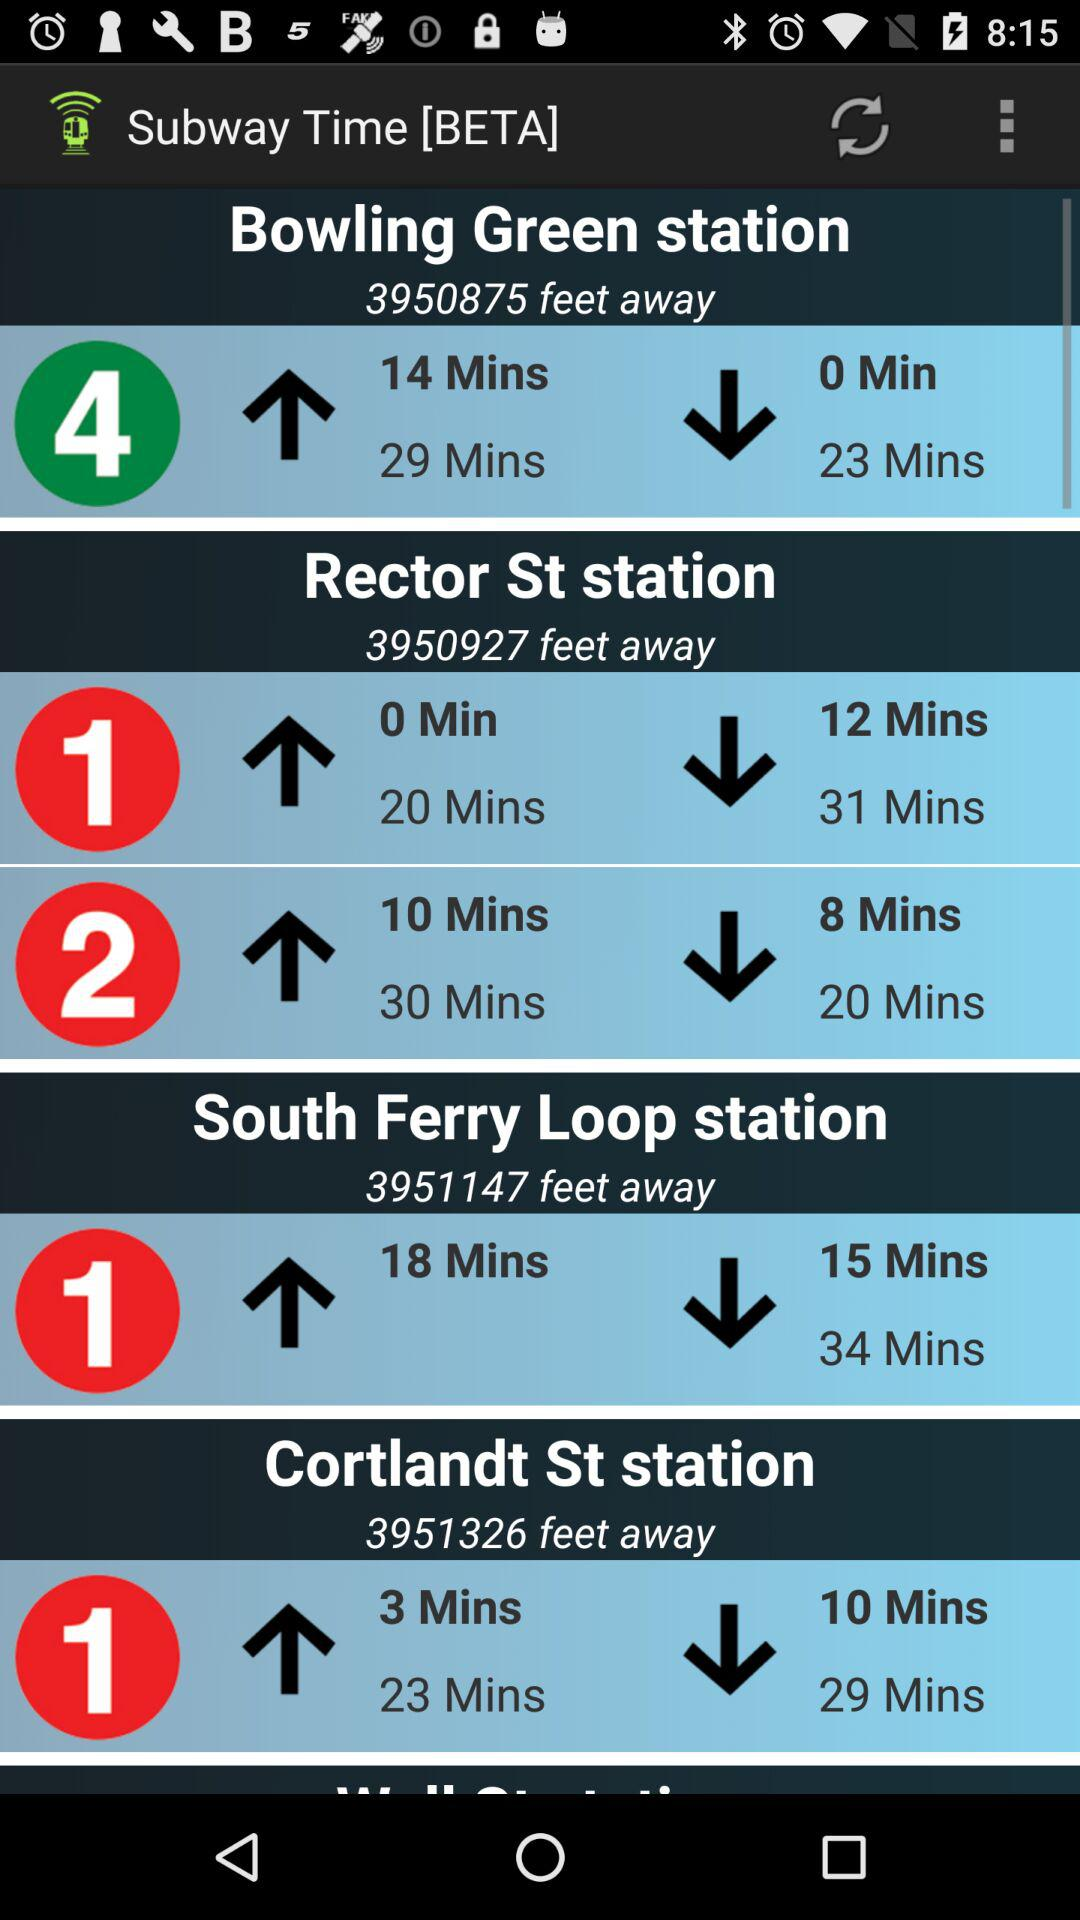How far is the "South Ferry Loop" station? The "South Ferry Loop" station is 3951147 feet away. 